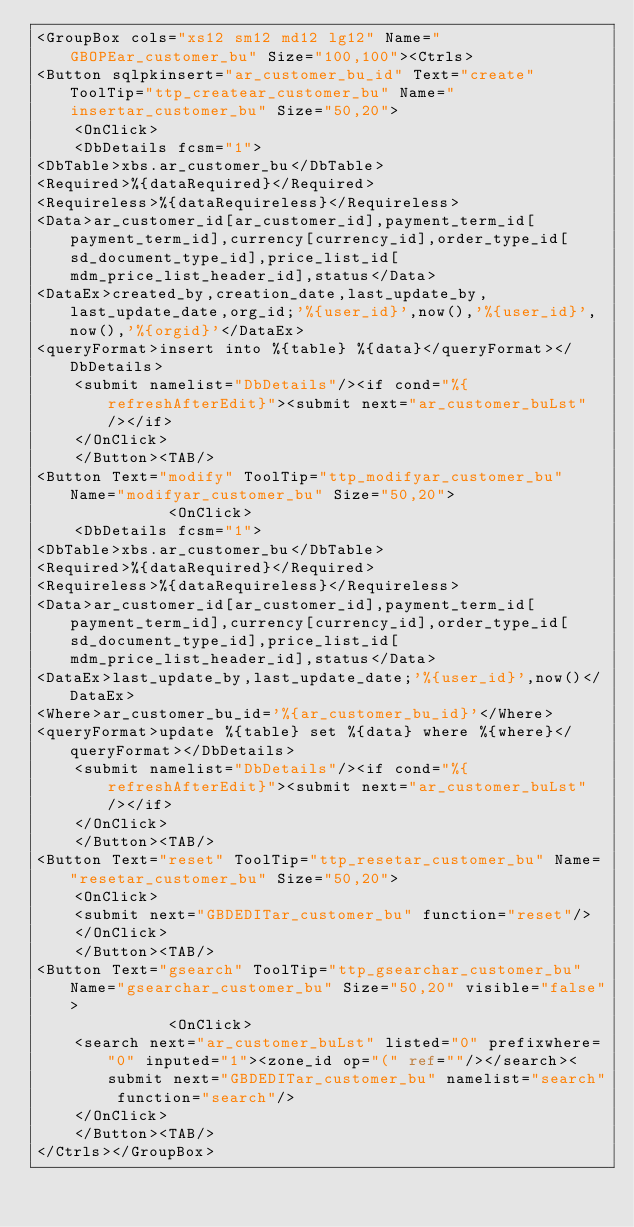Convert code to text. <code><loc_0><loc_0><loc_500><loc_500><_XML_><GroupBox cols="xs12 sm12 md12 lg12" Name="GBOPEar_customer_bu" Size="100,100"><Ctrls>
<Button sqlpkinsert="ar_customer_bu_id" Text="create" ToolTip="ttp_createar_customer_bu" Name="insertar_customer_bu" Size="50,20">
	<OnClick>
	<DbDetails fcsm="1">
<DbTable>xbs.ar_customer_bu</DbTable>
<Required>%{dataRequired}</Required>
<Requireless>%{dataRequireless}</Requireless>
<Data>ar_customer_id[ar_customer_id],payment_term_id[payment_term_id],currency[currency_id],order_type_id[sd_document_type_id],price_list_id[mdm_price_list_header_id],status</Data>
<DataEx>created_by,creation_date,last_update_by,last_update_date,org_id;'%{user_id}',now(),'%{user_id}',now(),'%{orgid}'</DataEx>
<queryFormat>insert into %{table} %{data}</queryFormat></DbDetails>
	<submit namelist="DbDetails"/><if cond="%{refreshAfterEdit}"><submit next="ar_customer_buLst"/></if>
	</OnClick>
	</Button><TAB/>
<Button Text="modify" ToolTip="ttp_modifyar_customer_bu" Name="modifyar_customer_bu" Size="50,20">
			  <OnClick>
	<DbDetails fcsm="1">
<DbTable>xbs.ar_customer_bu</DbTable>
<Required>%{dataRequired}</Required>
<Requireless>%{dataRequireless}</Requireless>
<Data>ar_customer_id[ar_customer_id],payment_term_id[payment_term_id],currency[currency_id],order_type_id[sd_document_type_id],price_list_id[mdm_price_list_header_id],status</Data>
<DataEx>last_update_by,last_update_date;'%{user_id}',now()</DataEx>
<Where>ar_customer_bu_id='%{ar_customer_bu_id}'</Where>
<queryFormat>update %{table} set %{data} where %{where}</queryFormat></DbDetails>
	<submit namelist="DbDetails"/><if cond="%{refreshAfterEdit}"><submit next="ar_customer_buLst"/></if>
	</OnClick>
	</Button><TAB/>
<Button Text="reset" ToolTip="ttp_resetar_customer_bu" Name="resetar_customer_bu" Size="50,20">
	<OnClick>
	<submit next="GBDEDITar_customer_bu" function="reset"/>
	</OnClick>
	</Button><TAB/>
<Button Text="gsearch" ToolTip="ttp_gsearchar_customer_bu" Name="gsearchar_customer_bu" Size="50,20" visible="false">
			  <OnClick>
	<search next="ar_customer_buLst" listed="0" prefixwhere="0" inputed="1"><zone_id op="(" ref=""/></search><submit next="GBDEDITar_customer_bu" namelist="search" function="search"/>
	</OnClick>
	</Button><TAB/>
</Ctrls></GroupBox></code> 